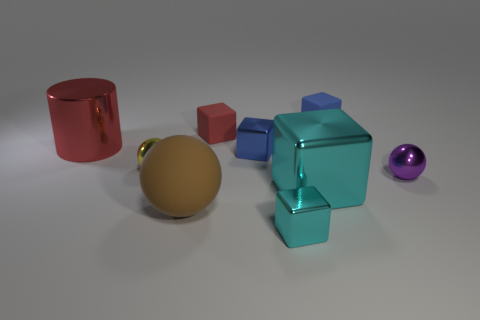What color is the small metallic sphere in front of the yellow ball?
Give a very brief answer. Purple. The yellow thing is what size?
Provide a short and direct response. Small. There is a large ball; is it the same color as the object that is behind the red rubber object?
Your response must be concise. No. There is a object on the left side of the sphere on the left side of the brown ball; what color is it?
Your answer should be compact. Red. Are there any other things that have the same size as the cylinder?
Provide a succinct answer. Yes. Does the matte thing in front of the red shiny cylinder have the same shape as the large red metallic object?
Make the answer very short. No. How many objects are behind the yellow thing and on the left side of the large brown object?
Keep it short and to the point. 1. What is the color of the small metallic sphere in front of the small yellow metallic ball that is left of the blue block that is behind the big red cylinder?
Give a very brief answer. Purple. How many small purple metal things are behind the tiny ball that is on the left side of the big brown rubber sphere?
Offer a very short reply. 0. How many other objects are the same shape as the yellow metallic object?
Provide a short and direct response. 2. 